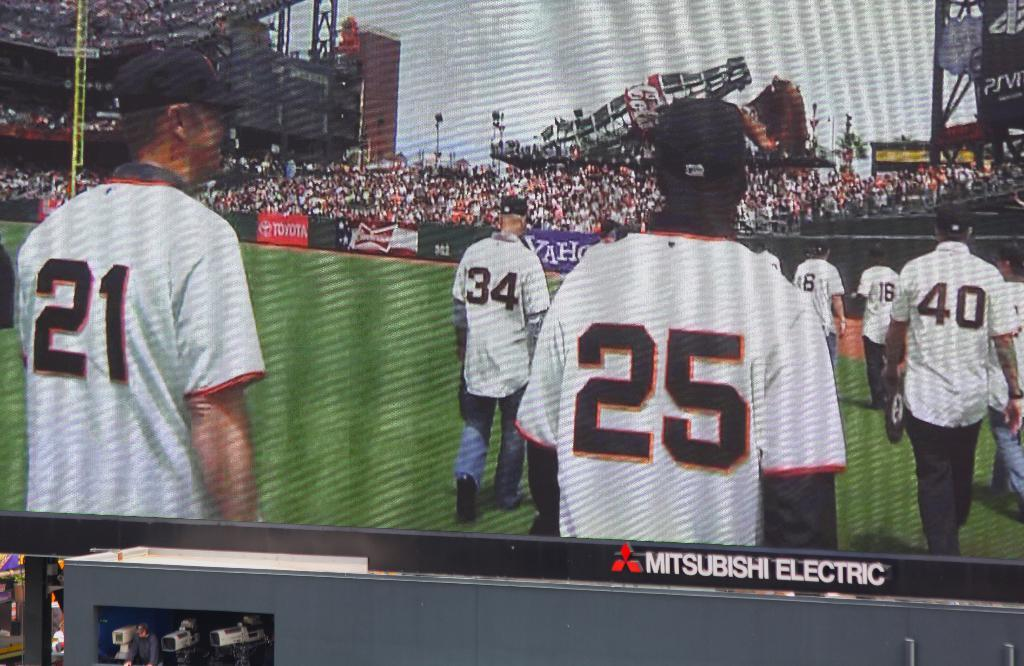What is the main feature of the image? There is a huge screen in the image. What is happening on the screen? There are people standing on the screen, and there are boards visible on the screen. Where is the image likely taken? The presence of a stadium suggests that the image is taken at a sports or entertainment event. What else can be seen in the image besides the screen? There are people in the stadium, trees, light poles, and the sky is visible in the image. What type of hammer is being used by the person on vacation in the image? There is no person on vacation or hammer present in the image. How does the sponge help the people on the screen in the image? There is no sponge present in the image, and therefore it cannot help the people on the screen. 